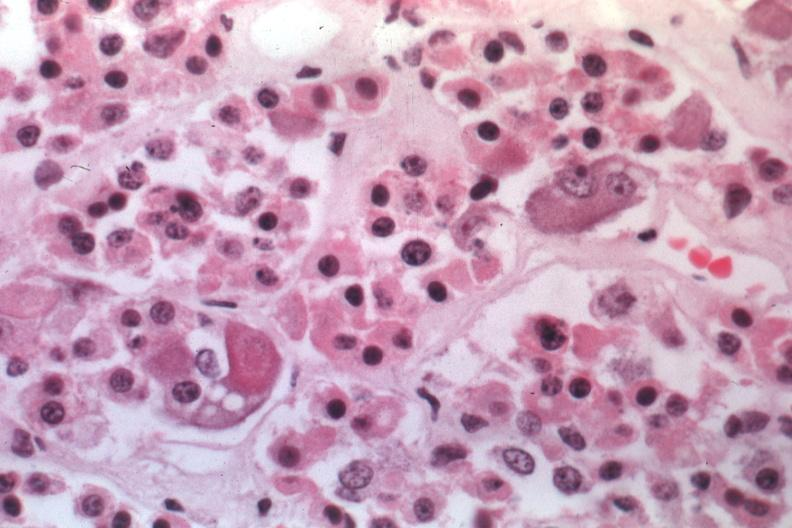s crookes cells present?
Answer the question using a single word or phrase. Yes 